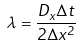<formula> <loc_0><loc_0><loc_500><loc_500>\lambda = \frac { D _ { x } \Delta t } { 2 \Delta x ^ { 2 } }</formula> 